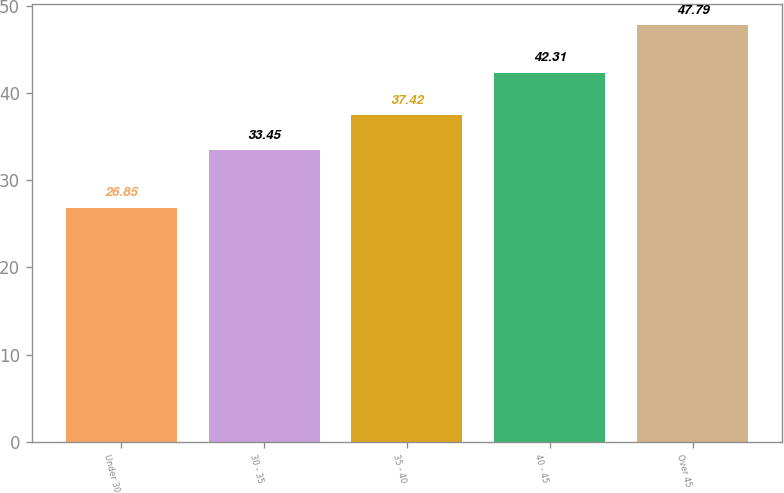Convert chart. <chart><loc_0><loc_0><loc_500><loc_500><bar_chart><fcel>Under 30<fcel>30 - 35<fcel>35 - 40<fcel>40 - 45<fcel>Over 45<nl><fcel>26.85<fcel>33.45<fcel>37.42<fcel>42.31<fcel>47.79<nl></chart> 